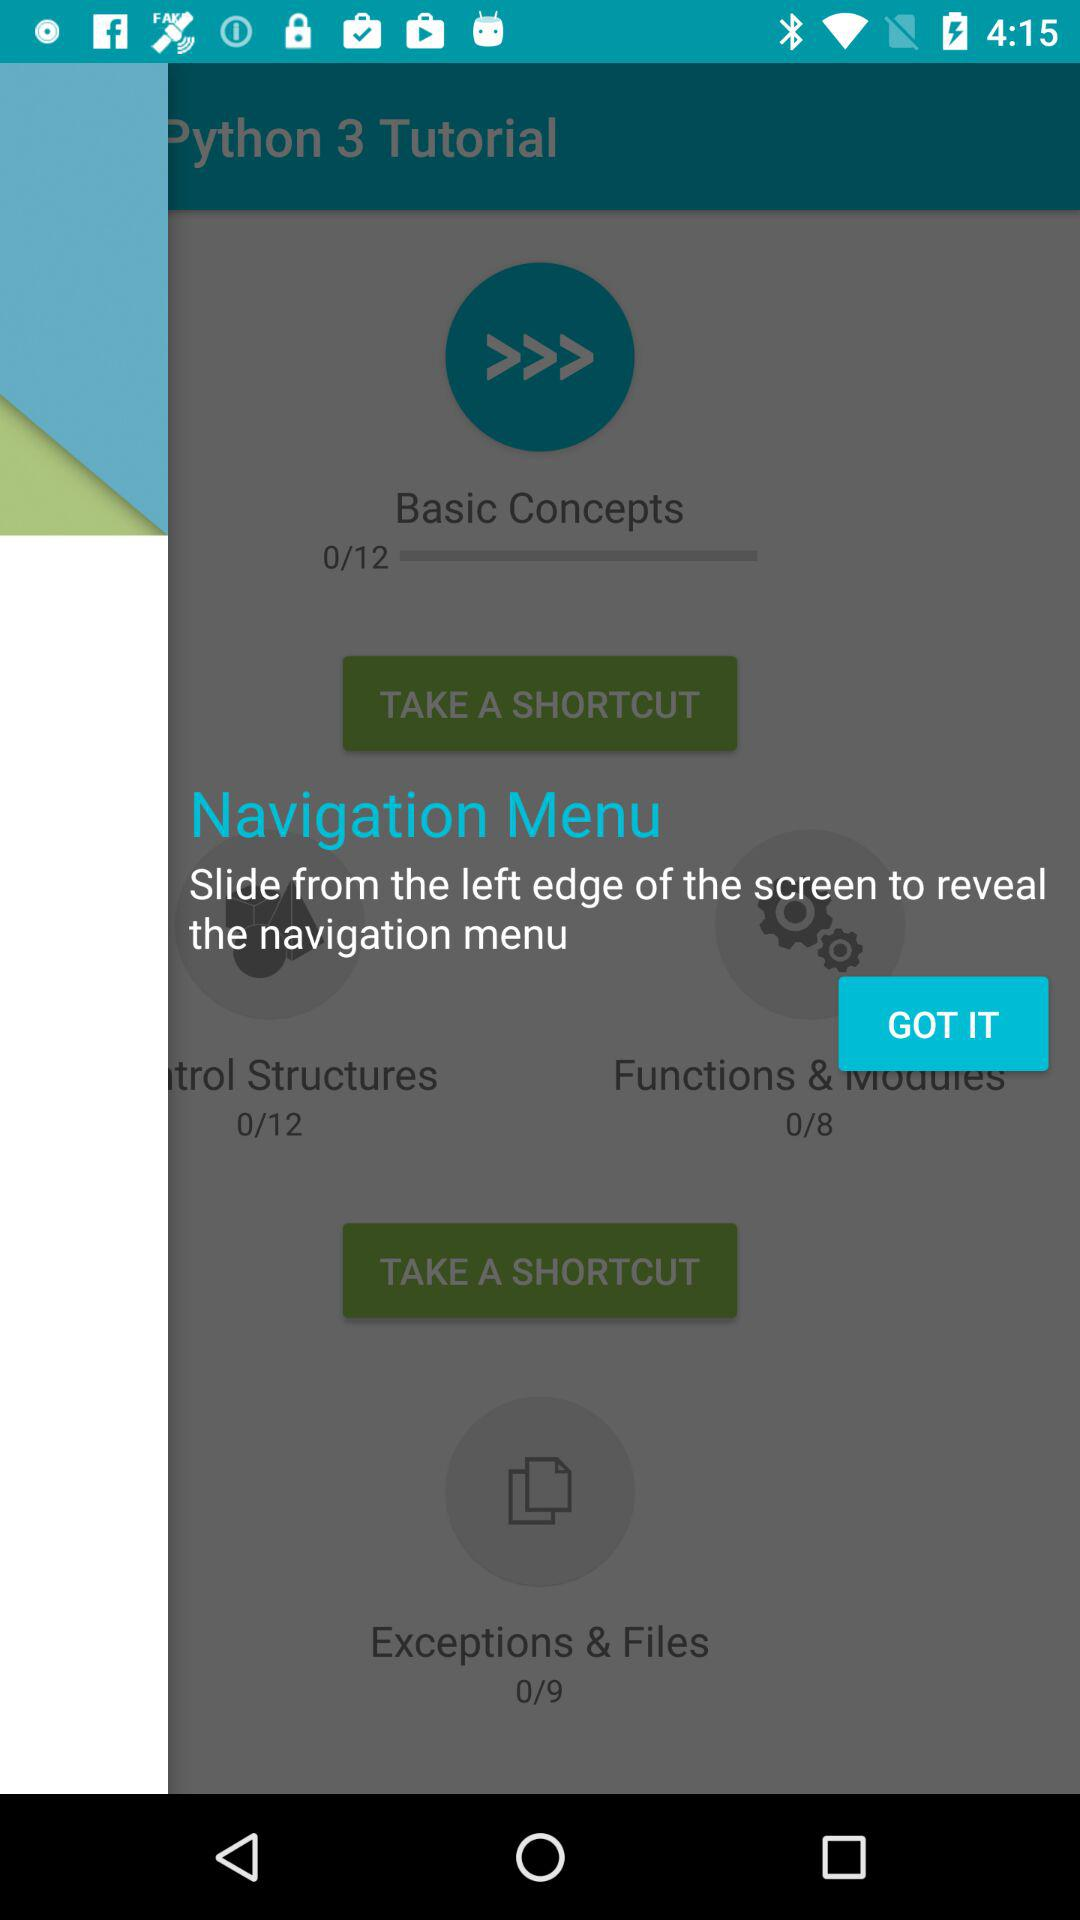How many "Exceptions & Files" in total are there? There are 9 "Exceptions & Files" in total. 